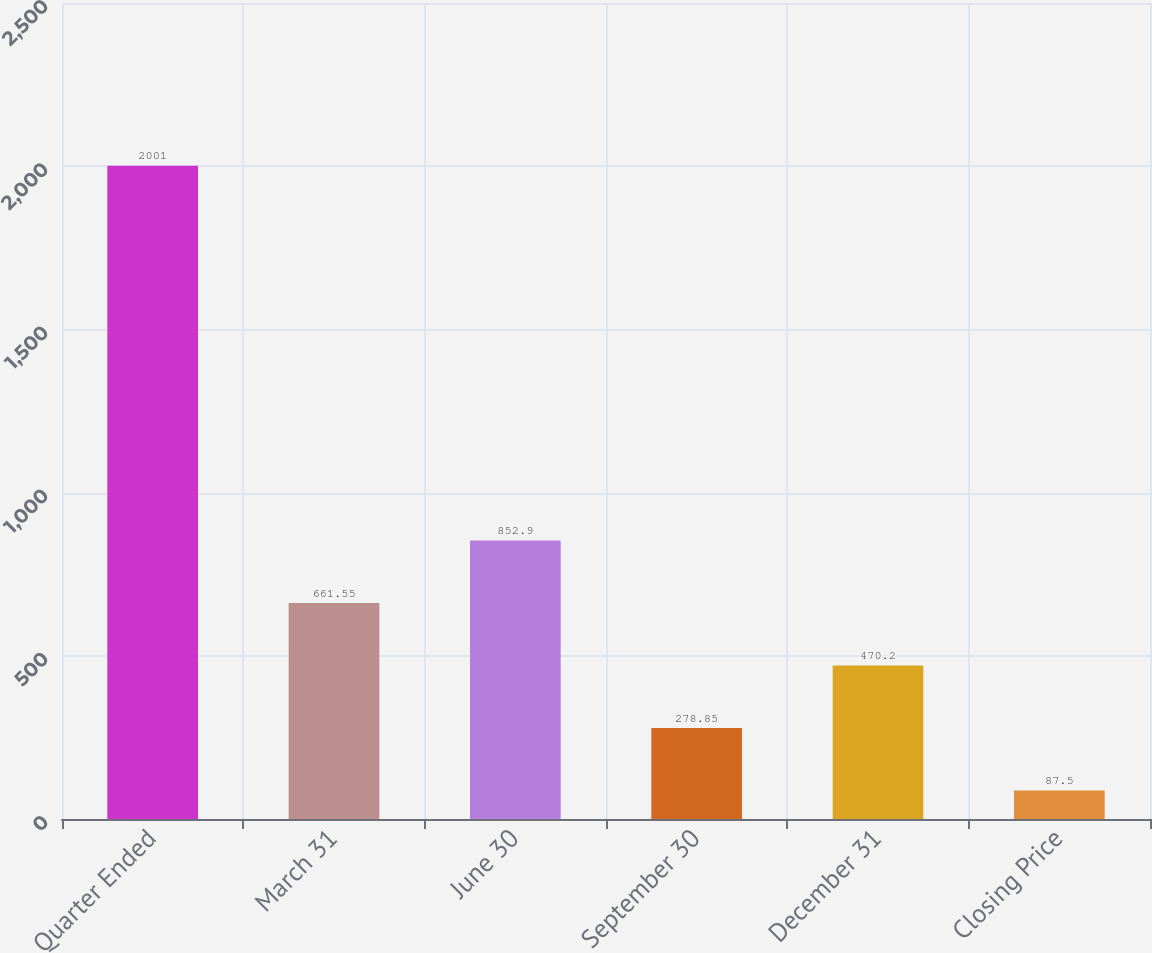Convert chart. <chart><loc_0><loc_0><loc_500><loc_500><bar_chart><fcel>Quarter Ended<fcel>March 31<fcel>June 30<fcel>September 30<fcel>December 31<fcel>Closing Price<nl><fcel>2001<fcel>661.55<fcel>852.9<fcel>278.85<fcel>470.2<fcel>87.5<nl></chart> 